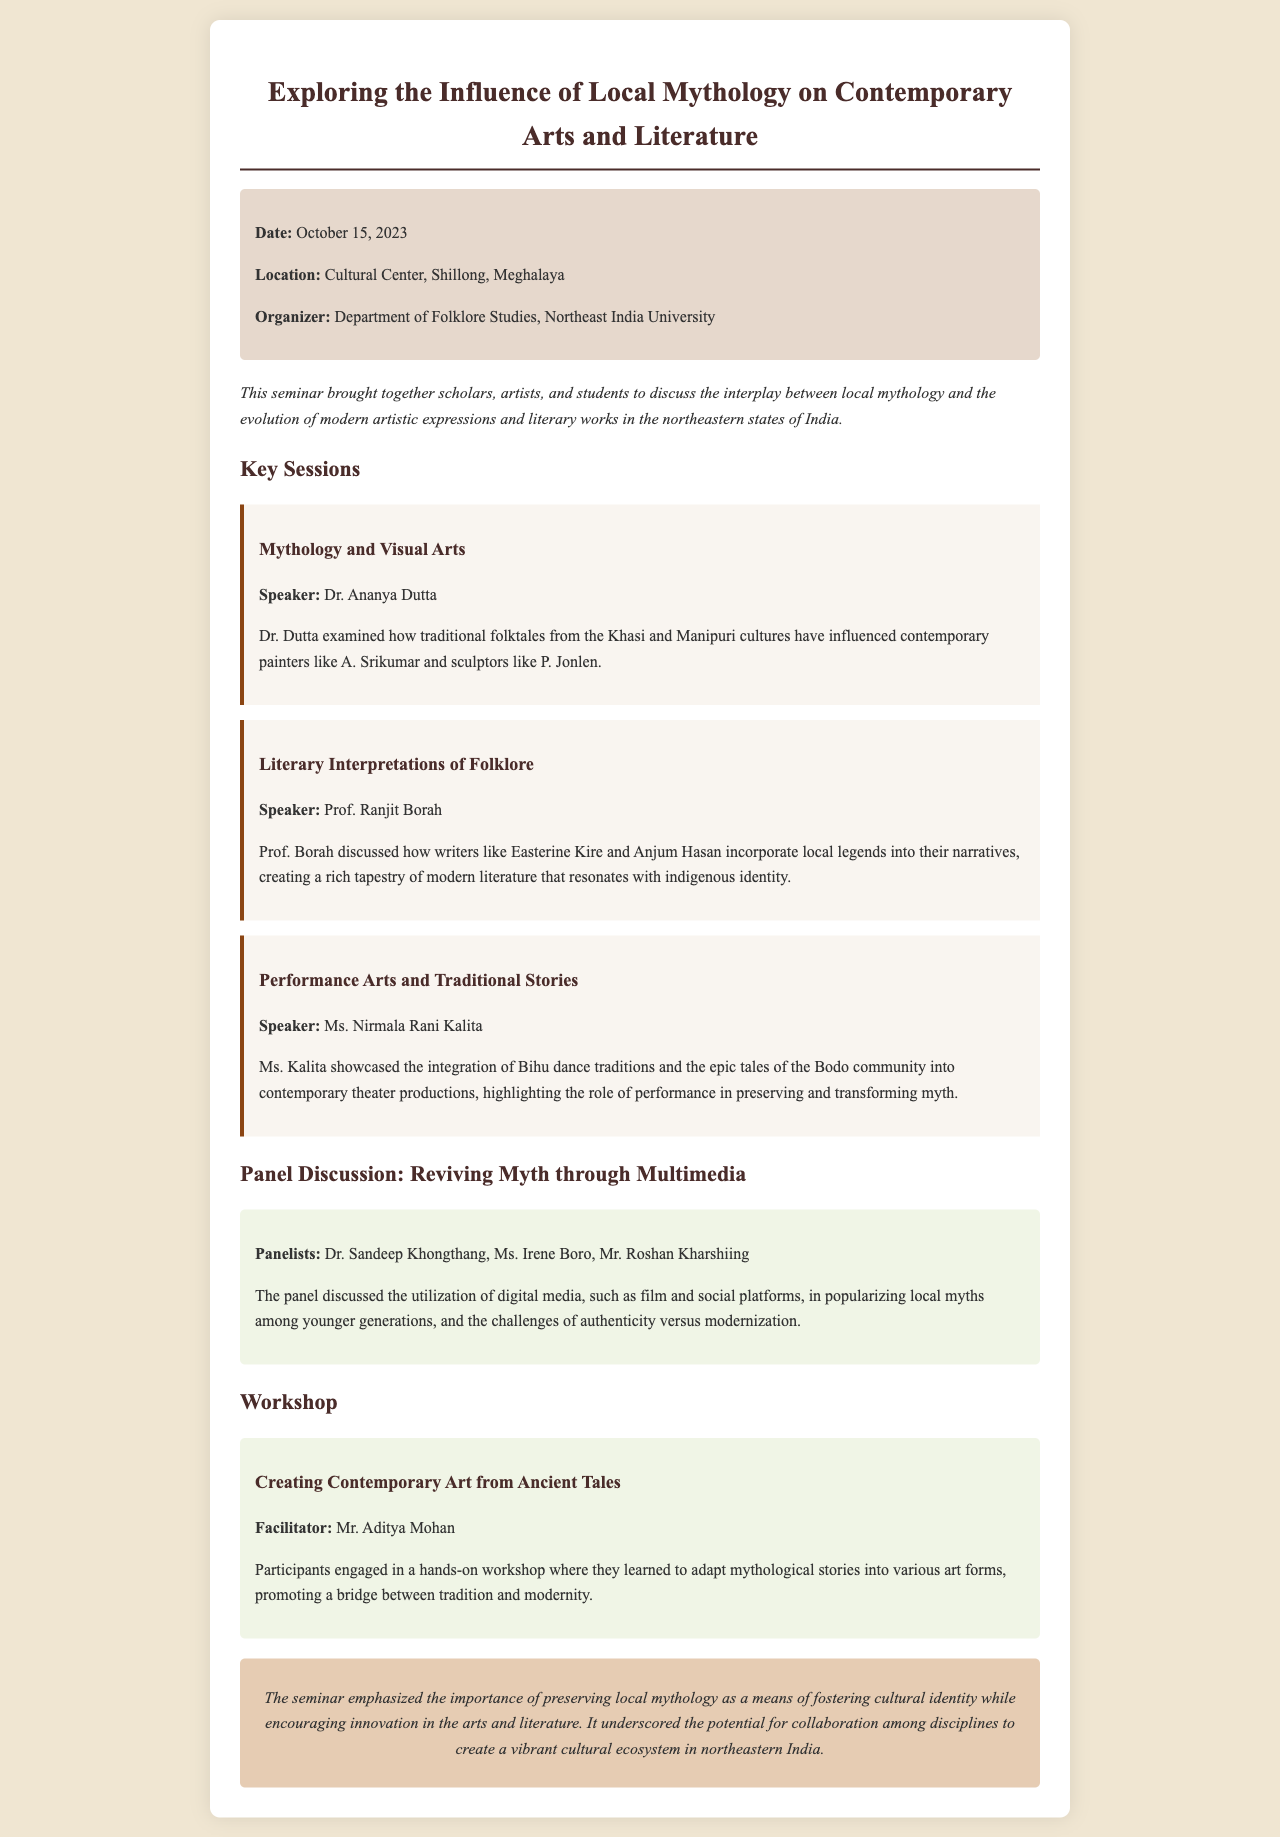What was the date of the seminar? The date of the seminar is specified in the document.
Answer: October 15, 2023 Who organized the seminar? The organizer of the seminar is mentioned in the document.
Answer: Department of Folklore Studies, Northeast India University Which speaker discussed "Mythology and Visual Arts"? The document states which speaker was assigned to this session.
Answer: Dr. Ananya Dutta What is the main focus of the workshop mentioned? The document describes what participants learned in the workshop.
Answer: Creating Contemporary Art from Ancient Tales Who were the panelists in the discussion about revitalizing myth? The document lists the participants in the panel discussion.
Answer: Dr. Sandeep Khongthang, Ms. Irene Boro, Mr. Roshan Kharshiing What role do local myths play in modern literature according to Prof. Ranjit Borah? The document gives insight into the relevance of local myths in literature.
Answer: Indigenous identity What type of art was integrated with Bihu dance traditions? The document explains the performance art discussed in the seminar.
Answer: Contemporary theater productions What was the conclusion of the seminar? The document summarizes the key point made about mythology and culture.
Answer: Preserving local mythology as a means of fostering cultural identity 